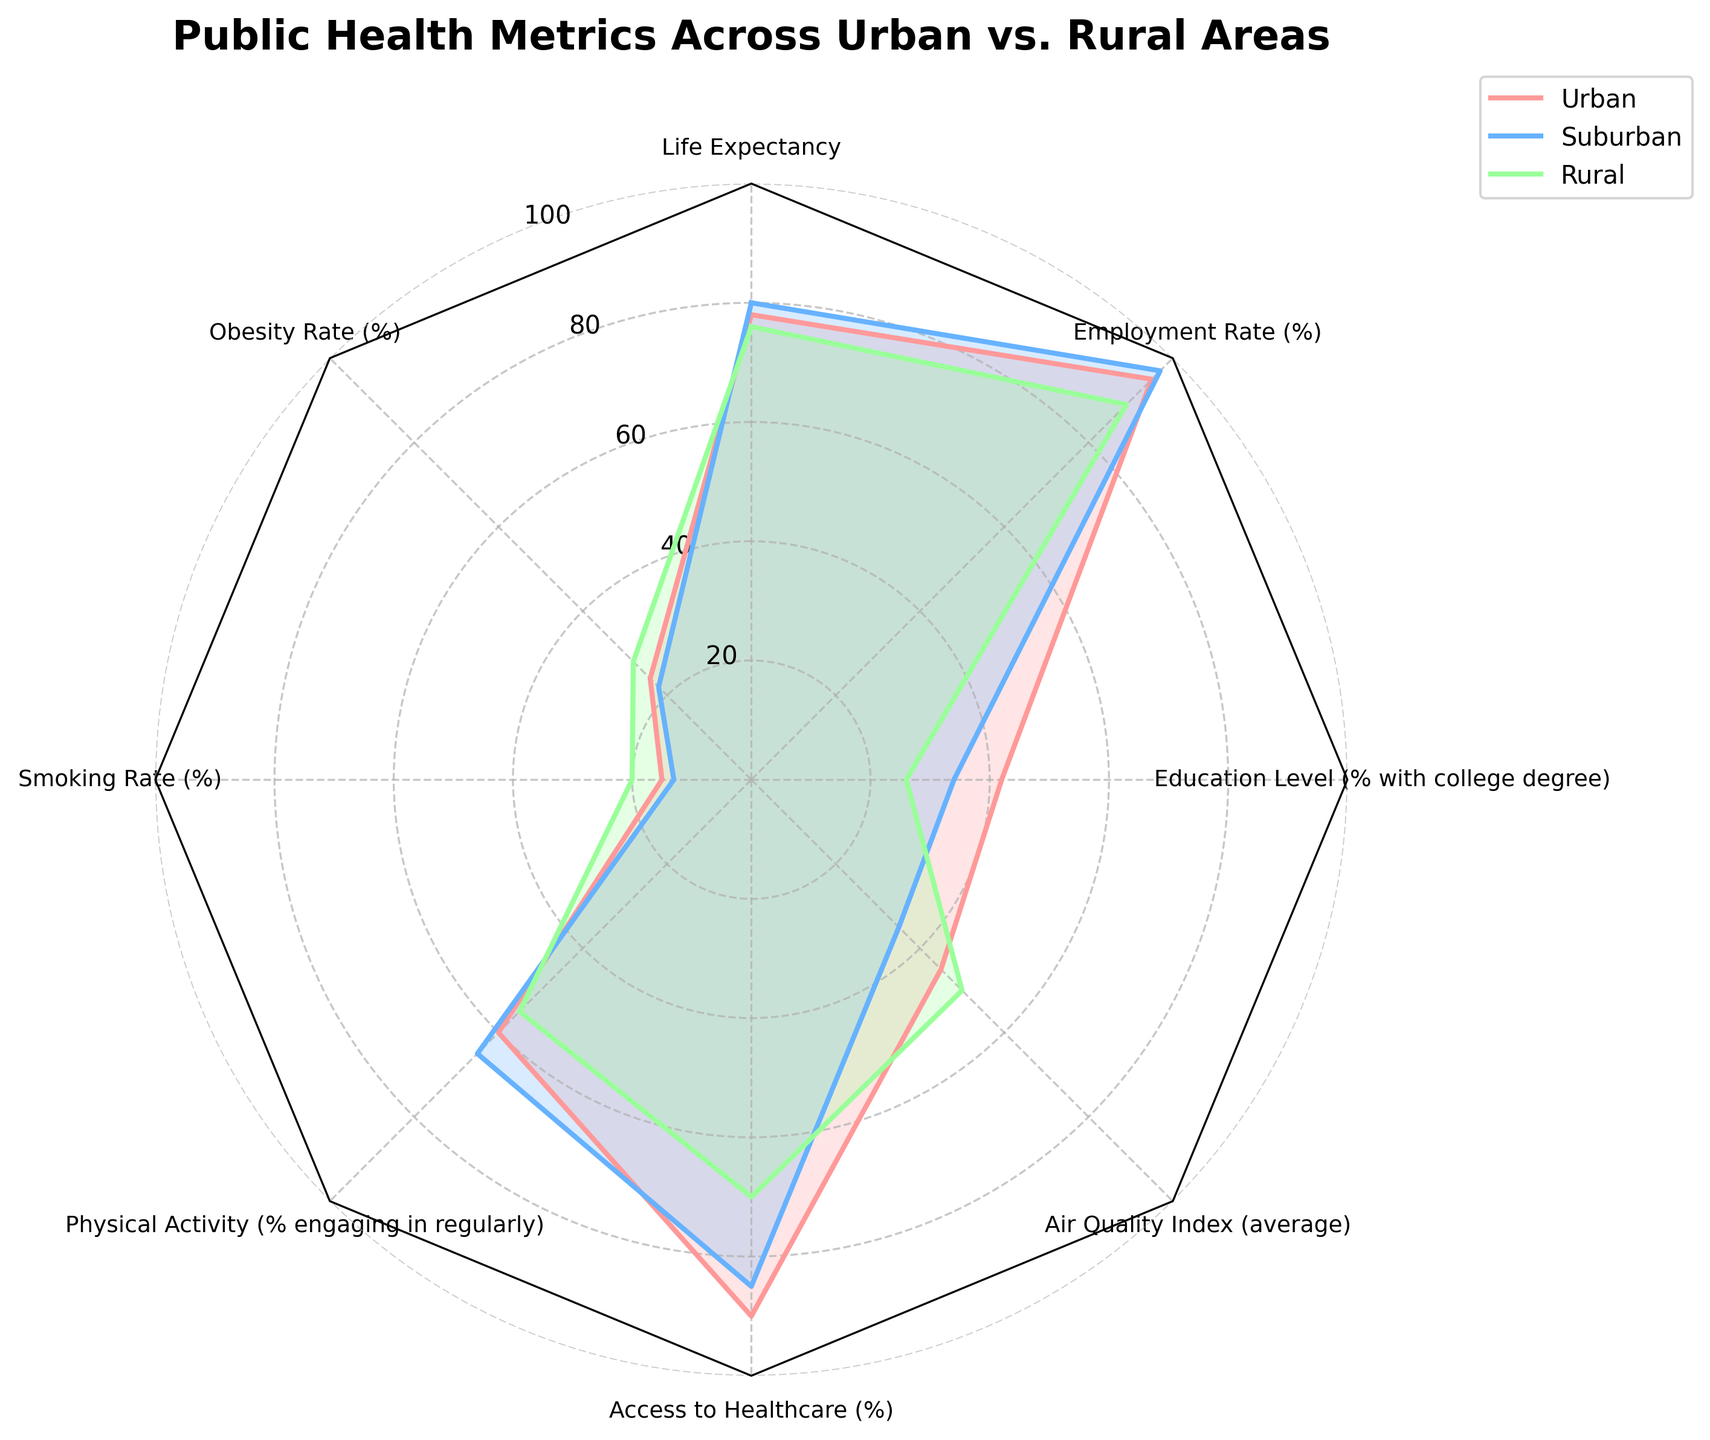What is the title of the figure? The title of the figure is usually found at the top center of the chart. Here, it is clearly indicated above the radar chart with a larger and bold font.
Answer: Public Health Metrics Across Urban vs. Rural Areas What metric has the highest percentage for urban areas? Identify the line representing urban areas, which is the red line according to the legend. Find the metric where this line reaches the highest point. In this case, it is the Employment Rate at 95%.
Answer: Employment Rate Which area has the highest obesity rate? Look at where the obesity rate metric is plotted on the radar chart and see which area's line reaches the furthest. Here, the green (Rural) has the highest point at the Obesity Rate metric.
Answer: Rural What is the difference in the life expectancy between rural and urban areas? Find the values for Life Expectancy for both rural and urban areas from the radar chart or legend: Rural (76) and Urban (78). Then, subtract the rural value from the urban value: 78 - 76.
Answer: 2 years Which area has the best air quality? Look at the Air Quality Index metric on the radar chart and identify which area's line reaches the lowest point, since lower values indicate better air quality. Here, blue (Suburban) reaches the lowest point at Air Quality Index.
Answer: Suburban What is the average percentage of people with a college degree across all three areas? Find the values for the Education Level metric: Urban (42), Suburban (34), and Rural (26). Calculate the average: (42 + 34 + 26) / 3.
Answer: 34 How do urban and suburban areas compare in terms of physical activity? Look at the Physical Activity metric and compare the values of Urban (60) and Suburban (65) directly on the radar chart.
Answer: Suburban is higher In which area is access to healthcare the lowest? Find the Access to Healthcare metric and see which area has the lowest point, according to the radar chart. Here, green (Rural) is the lowest at this metric.
Answer: Rural What is the employment rate difference between suburban and rural areas? Look at the Employment Rate metric and get the values for Suburban (97) and Rural (89). Subtract the rural value from the suburban value: 97 - 89.
Answer: 8% Which metric shows the most significant disparity between urban and rural areas? Evaluate each metric on the radar chart and identify where the urban and rural lines differ the most significantly. The Access to Healthcare metric shows a large disparity, with Urban (90) and Rural (70).
Answer: Access to Healthcare 